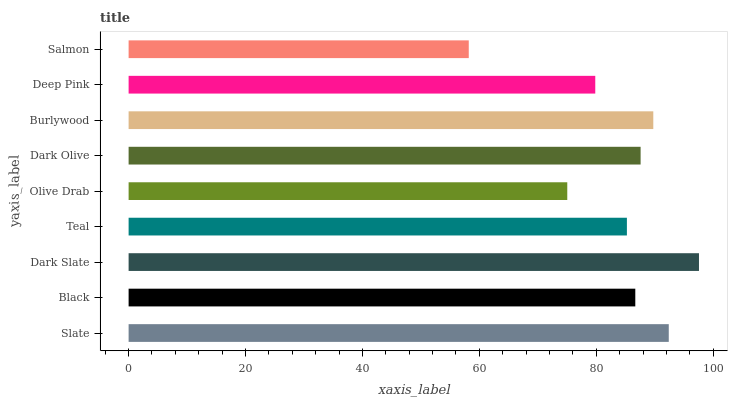Is Salmon the minimum?
Answer yes or no. Yes. Is Dark Slate the maximum?
Answer yes or no. Yes. Is Black the minimum?
Answer yes or no. No. Is Black the maximum?
Answer yes or no. No. Is Slate greater than Black?
Answer yes or no. Yes. Is Black less than Slate?
Answer yes or no. Yes. Is Black greater than Slate?
Answer yes or no. No. Is Slate less than Black?
Answer yes or no. No. Is Black the high median?
Answer yes or no. Yes. Is Black the low median?
Answer yes or no. Yes. Is Burlywood the high median?
Answer yes or no. No. Is Slate the low median?
Answer yes or no. No. 